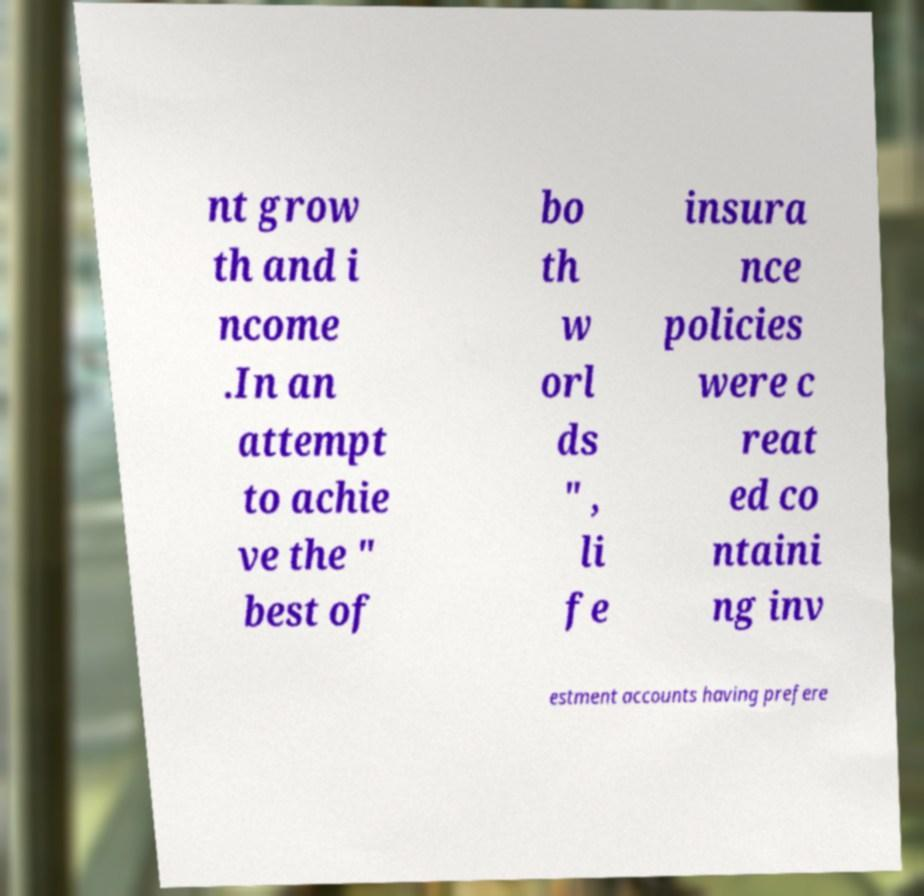Can you accurately transcribe the text from the provided image for me? nt grow th and i ncome .In an attempt to achie ve the " best of bo th w orl ds " , li fe insura nce policies were c reat ed co ntaini ng inv estment accounts having prefere 